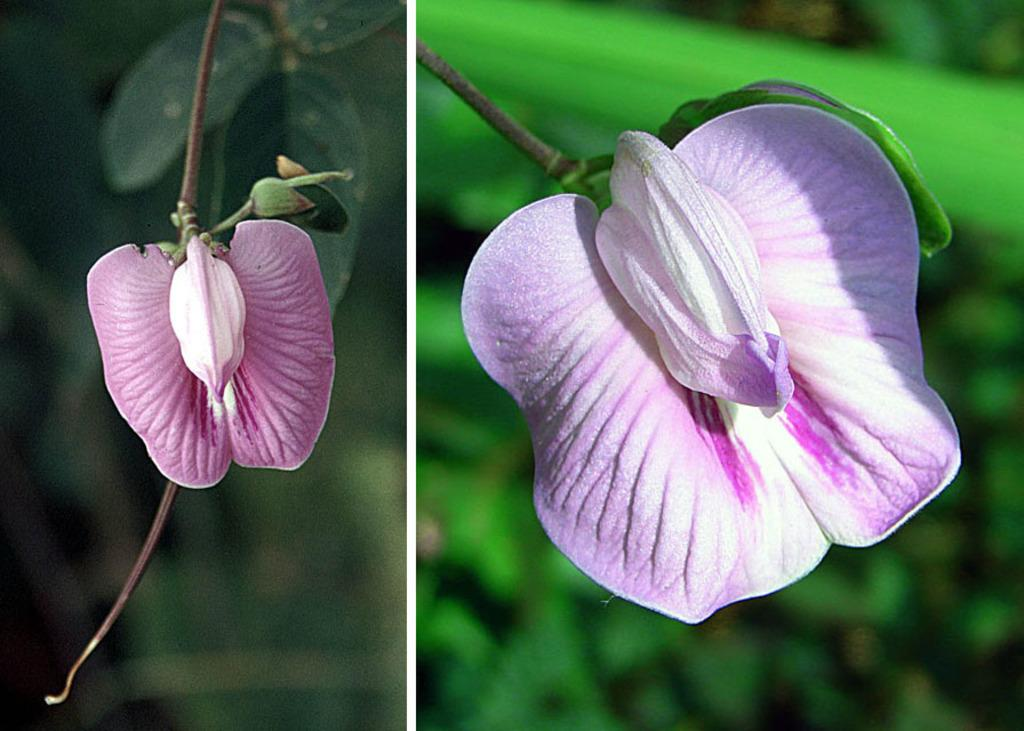What type of artwork is depicted in the image? The image is a collage. What is the main subject of the collage? There are flowers in the center of the image. What color are the flowers in the collage? The flowers are pink in color. What can be seen in the background of the collage? There are plants in the background of the image. What time of day is it in the image, based on the presence of cars? There are no cars present in the image, so it is not possible to determine the time of day based on this information. 